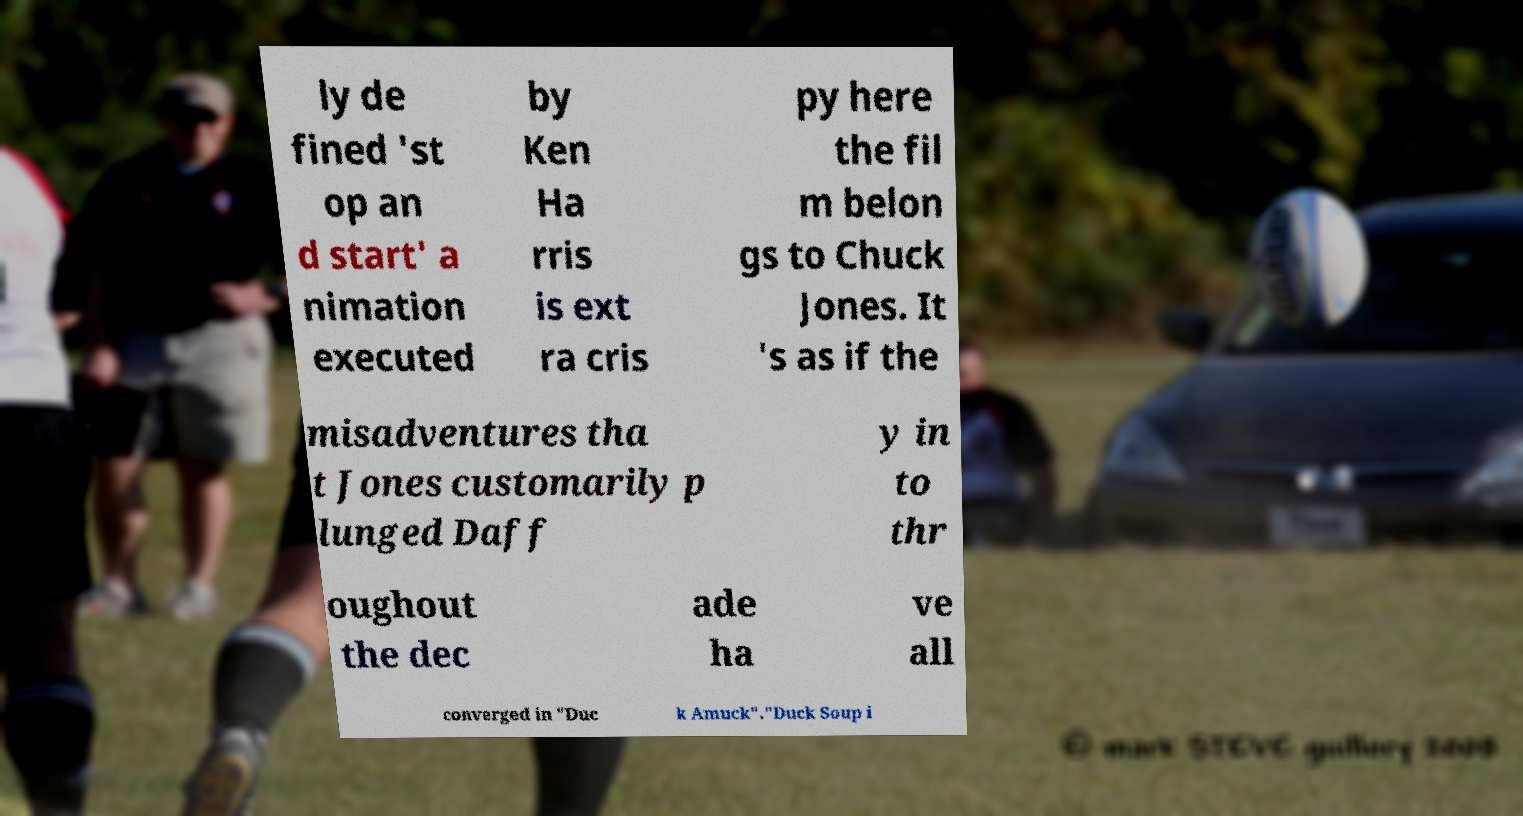Please read and relay the text visible in this image. What does it say? ly de fined 'st op an d start' a nimation executed by Ken Ha rris is ext ra cris py here the fil m belon gs to Chuck Jones. It 's as if the misadventures tha t Jones customarily p lunged Daff y in to thr oughout the dec ade ha ve all converged in "Duc k Amuck"."Duck Soup i 